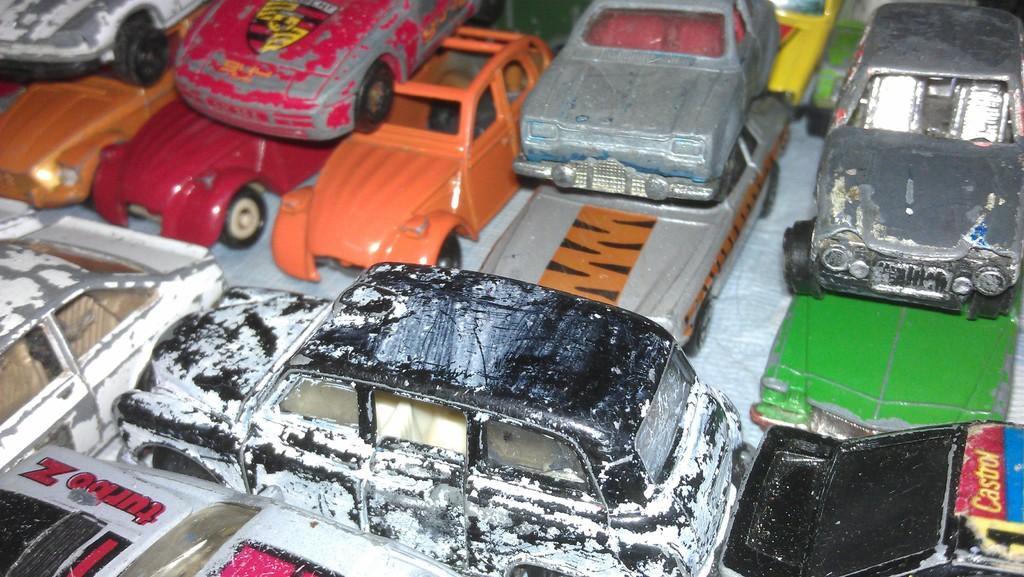How would you summarize this image in a sentence or two? In this image we can see a group of toy vehicles placed on the surface. 